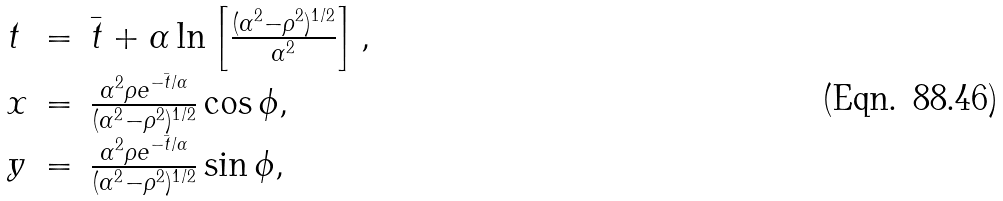Convert formula to latex. <formula><loc_0><loc_0><loc_500><loc_500>\begin{array} { l c l } t & = & \bar { t } + \alpha \ln \left [ \frac { ( \alpha ^ { 2 } - \rho ^ { 2 } ) ^ { 1 / 2 } } { \alpha ^ { 2 } } \right ] , \\ x & = & \frac { \alpha ^ { 2 } \rho e ^ { - \bar { t } / \alpha } } { ( \alpha ^ { 2 } - \rho ^ { 2 } ) ^ { 1 / 2 } } \cos \phi , \\ y & = & \frac { \alpha ^ { 2 } \rho e ^ { - \bar { t } / \alpha } } { ( \alpha ^ { 2 } - \rho ^ { 2 } ) ^ { 1 / 2 } } \sin \phi , \end{array}</formula> 